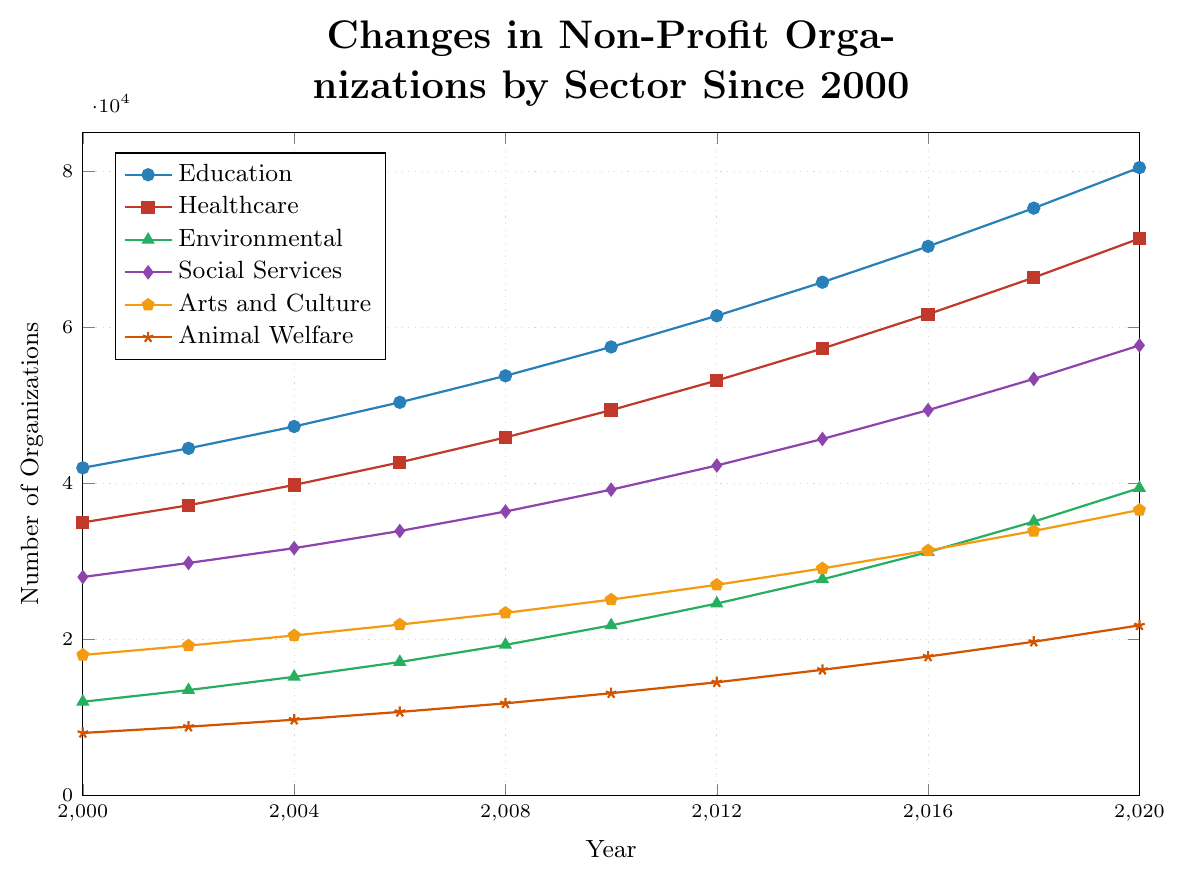Which sector had the highest number of non-profit organizations in 2020? Looking at the graph and identifying the highest point in 2020, we see that Education has the highest number of organizations.
Answer: Education How many more Education non-profit organizations were there in 2020 compared to 2000? From the graph, the number of Education organizations in 2000 is 42,000 and in 2020 it's 80,500. The difference is 80,500 - 42,000.
Answer: 38,500 What is the trend observed in the number of Healthcare non-profits from 2000 to 2020? By tracing the line for Healthcare (usually shown in red) from 2000 to 2020, the number of organizations increases steadily over the years.
Answer: Steadily increasing Which sector experienced the lowest growth in non-profit numbers from 2000 to 2020? By examining the graph, the line for Animal Welfare shows the lowest growth, starting with 8,000 in 2000 and reaching 21,800 in 2020.
Answer: Animal Welfare Between 2008 and 2012, which sector showed the most rapid increase in non-profit numbers? By comparing the relative steepness of the lines between 2008 and 2012, Environmental non-profits (typically green) show the sharpest incline.
Answer: Environmental What was the number of Social Services non-profits in 2016, and how does it compare to the number in 2006? From the plot, Social Services had 49,400 non-profits in 2016 and 33,900 in 2006. The difference is 49,400 - 33,900.
Answer: 15,500 How did the number of Arts and Culture non-profits change from 2010 to 2018? Looking at the Arts and Culture line, it increased from 25,100 in 2010 to 33,900 in 2018.
Answer: Increased What is the average number of Education non-profits between 2014 and 2020? The numbers from 2014 to 2020 are: 65,800, 70,400, 75,300, 80,500. The average is (65,800 + 70,400 + 75,300 + 80,500) / 4.
Answer: 73,000 Which sector had more non-profits in 2008: Social Services or Arts and Culture? By comparing the data points for 2008, Social Services had 36,400 and Arts and Culture had 23,400.
Answer: Social Services 